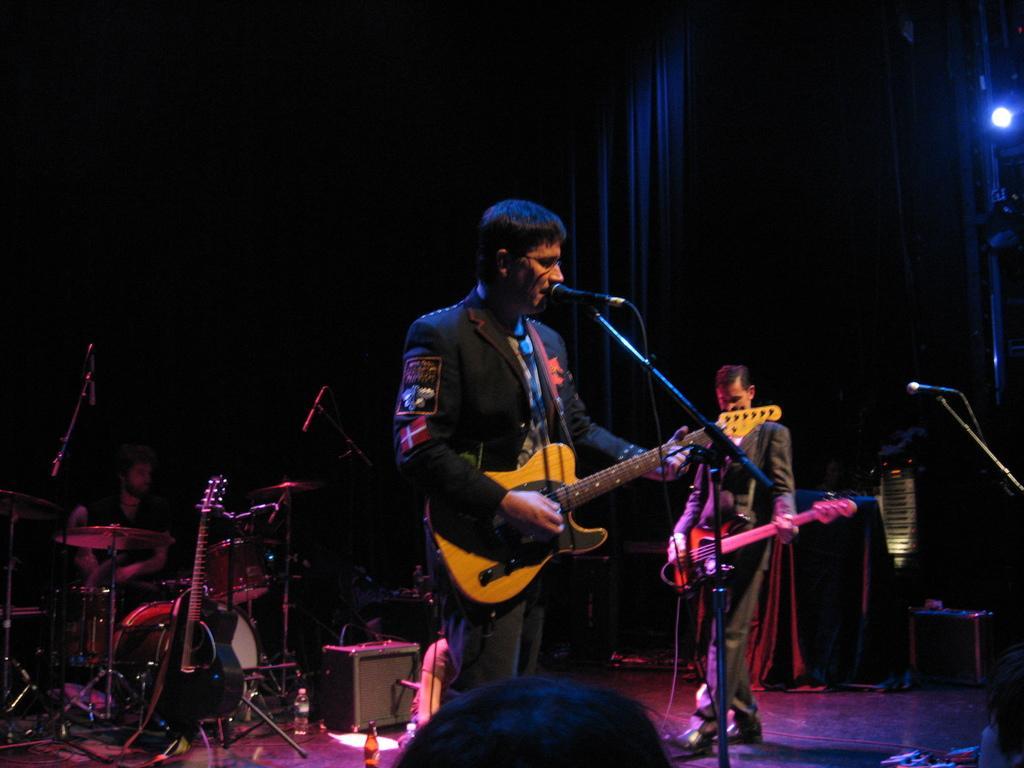Describe this image in one or two sentences. In this image I can see a person standing in front of the mic and playing guitar. At the right there is another person who is playing the same guitar. At the back there is a person sitting and playing the drum set. And these people are on the stage. 